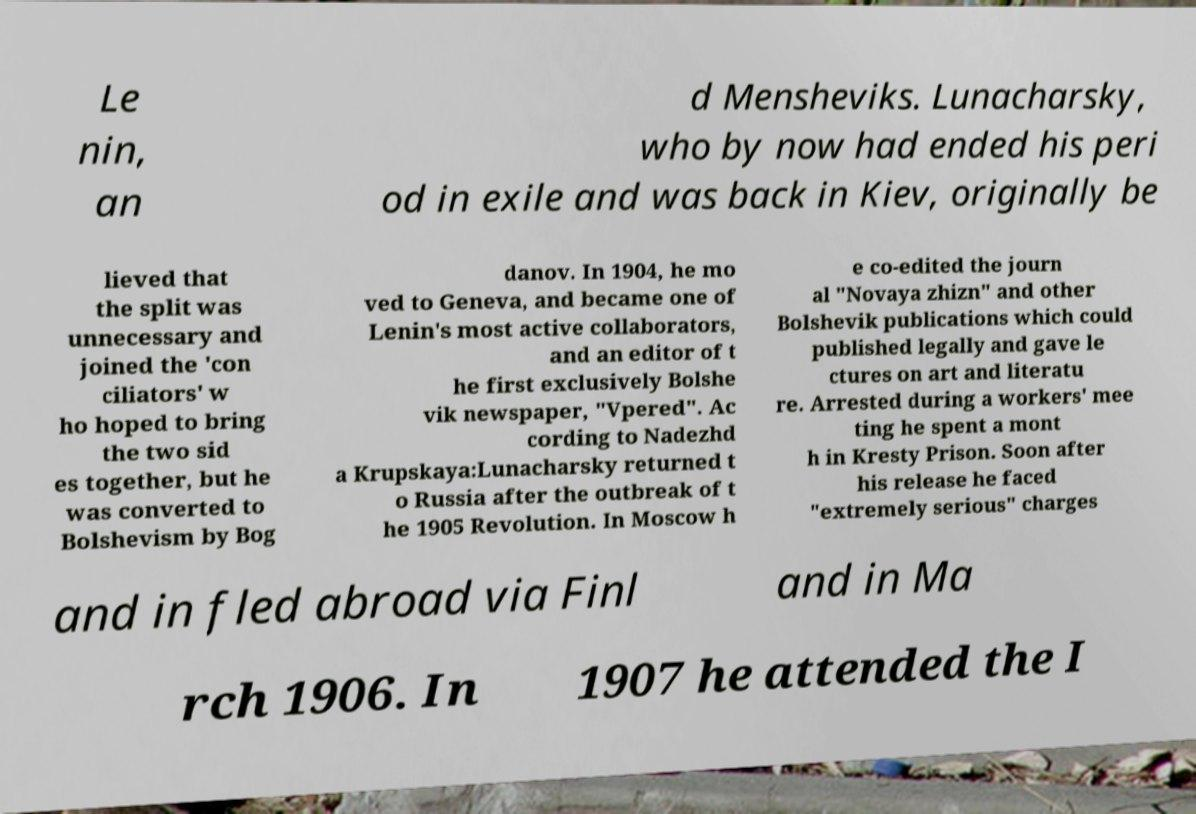What messages or text are displayed in this image? I need them in a readable, typed format. Le nin, an d Mensheviks. Lunacharsky, who by now had ended his peri od in exile and was back in Kiev, originally be lieved that the split was unnecessary and joined the 'con ciliators' w ho hoped to bring the two sid es together, but he was converted to Bolshevism by Bog danov. In 1904, he mo ved to Geneva, and became one of Lenin's most active collaborators, and an editor of t he first exclusively Bolshe vik newspaper, "Vpered". Ac cording to Nadezhd a Krupskaya:Lunacharsky returned t o Russia after the outbreak of t he 1905 Revolution. In Moscow h e co-edited the journ al "Novaya zhizn" and other Bolshevik publications which could published legally and gave le ctures on art and literatu re. Arrested during a workers' mee ting he spent a mont h in Kresty Prison. Soon after his release he faced "extremely serious" charges and in fled abroad via Finl and in Ma rch 1906. In 1907 he attended the I 